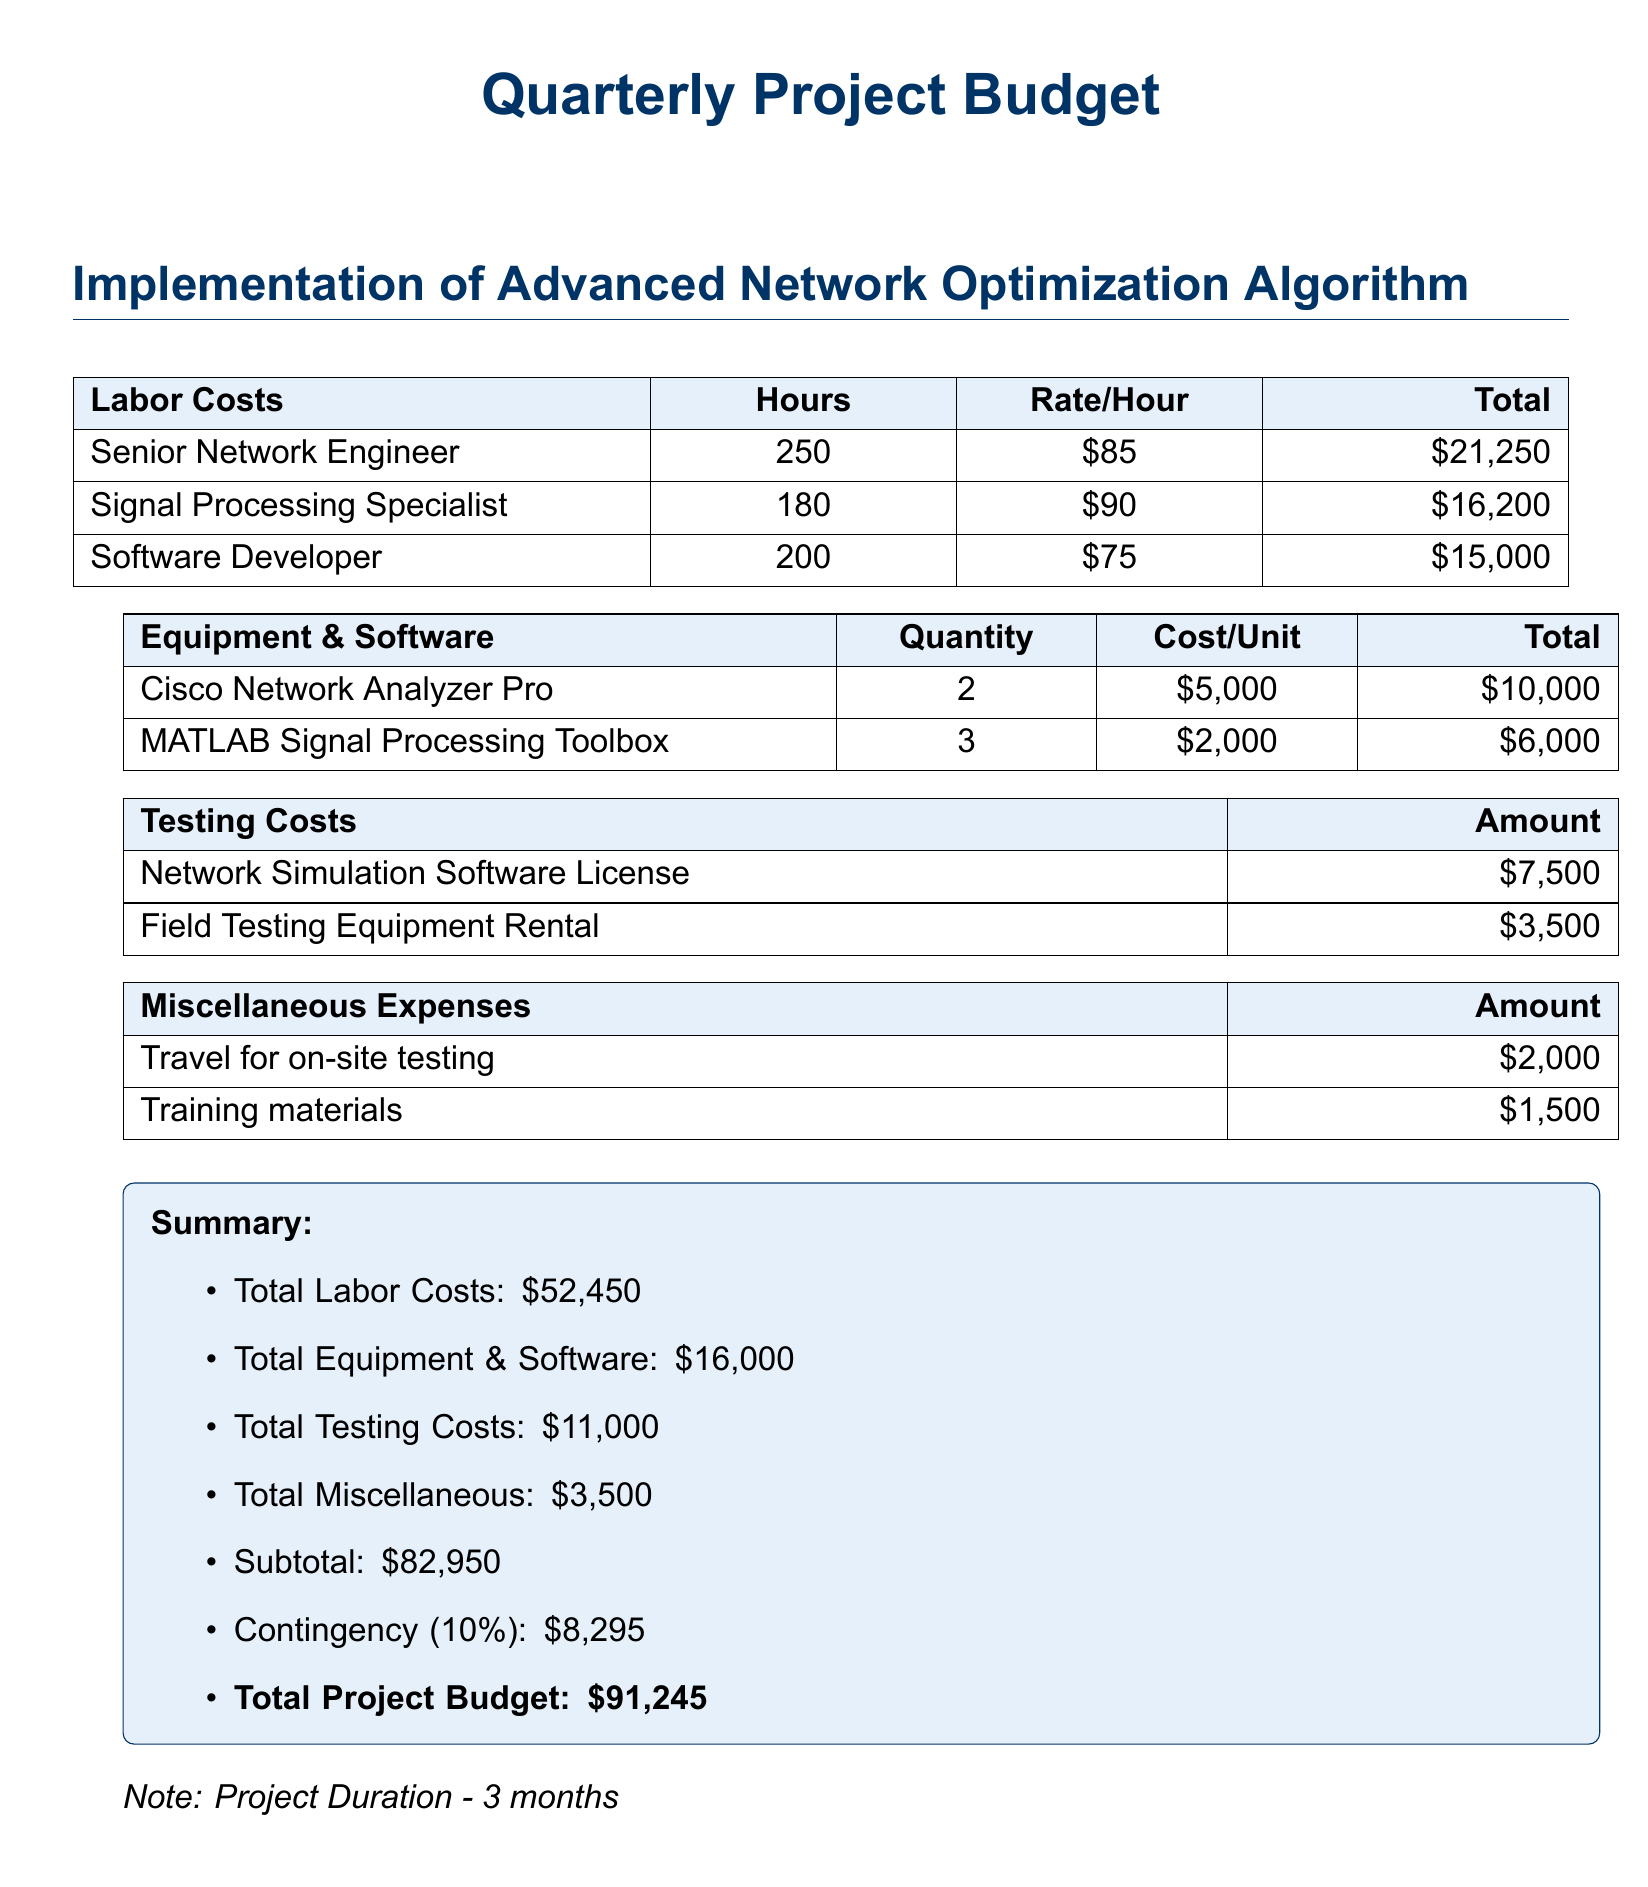What is the total labor cost? The total labor cost is provided in the summary section of the document.
Answer: $52,450 How many hours did the Senior Network Engineer work? The document lists the hours worked by each position, with the Senior Network Engineer working 250 hours.
Answer: 250 What is the cost of the Cisco Network Analyzer Pro? The cost of the Cisco Network Analyzer Pro is outlined in the equipment list.
Answer: $5,000 What is the total amount allocated for testing costs? The summary section includes the total amount of testing costs which combines the costs listed under testing.
Answer: $11,000 What is the contingency percentage applied to the budget? The budget summary includes a note about the contingency percentage which is explicitly stated.
Answer: 10% How much budget is allocated for travel for on-site testing? The miscellaneous expenses tabulates the amount allocated for travel, which is detailed in that section.
Answer: $2,000 How many units of MATLAB Signal Processing Toolbox are being purchased? The equipment list specifies the number of units being purchased for the MATLAB Signal Processing Toolbox.
Answer: 3 What is the total project budget? The total project budget is clearly summarized at the end of the document.
Answer: $91,245 